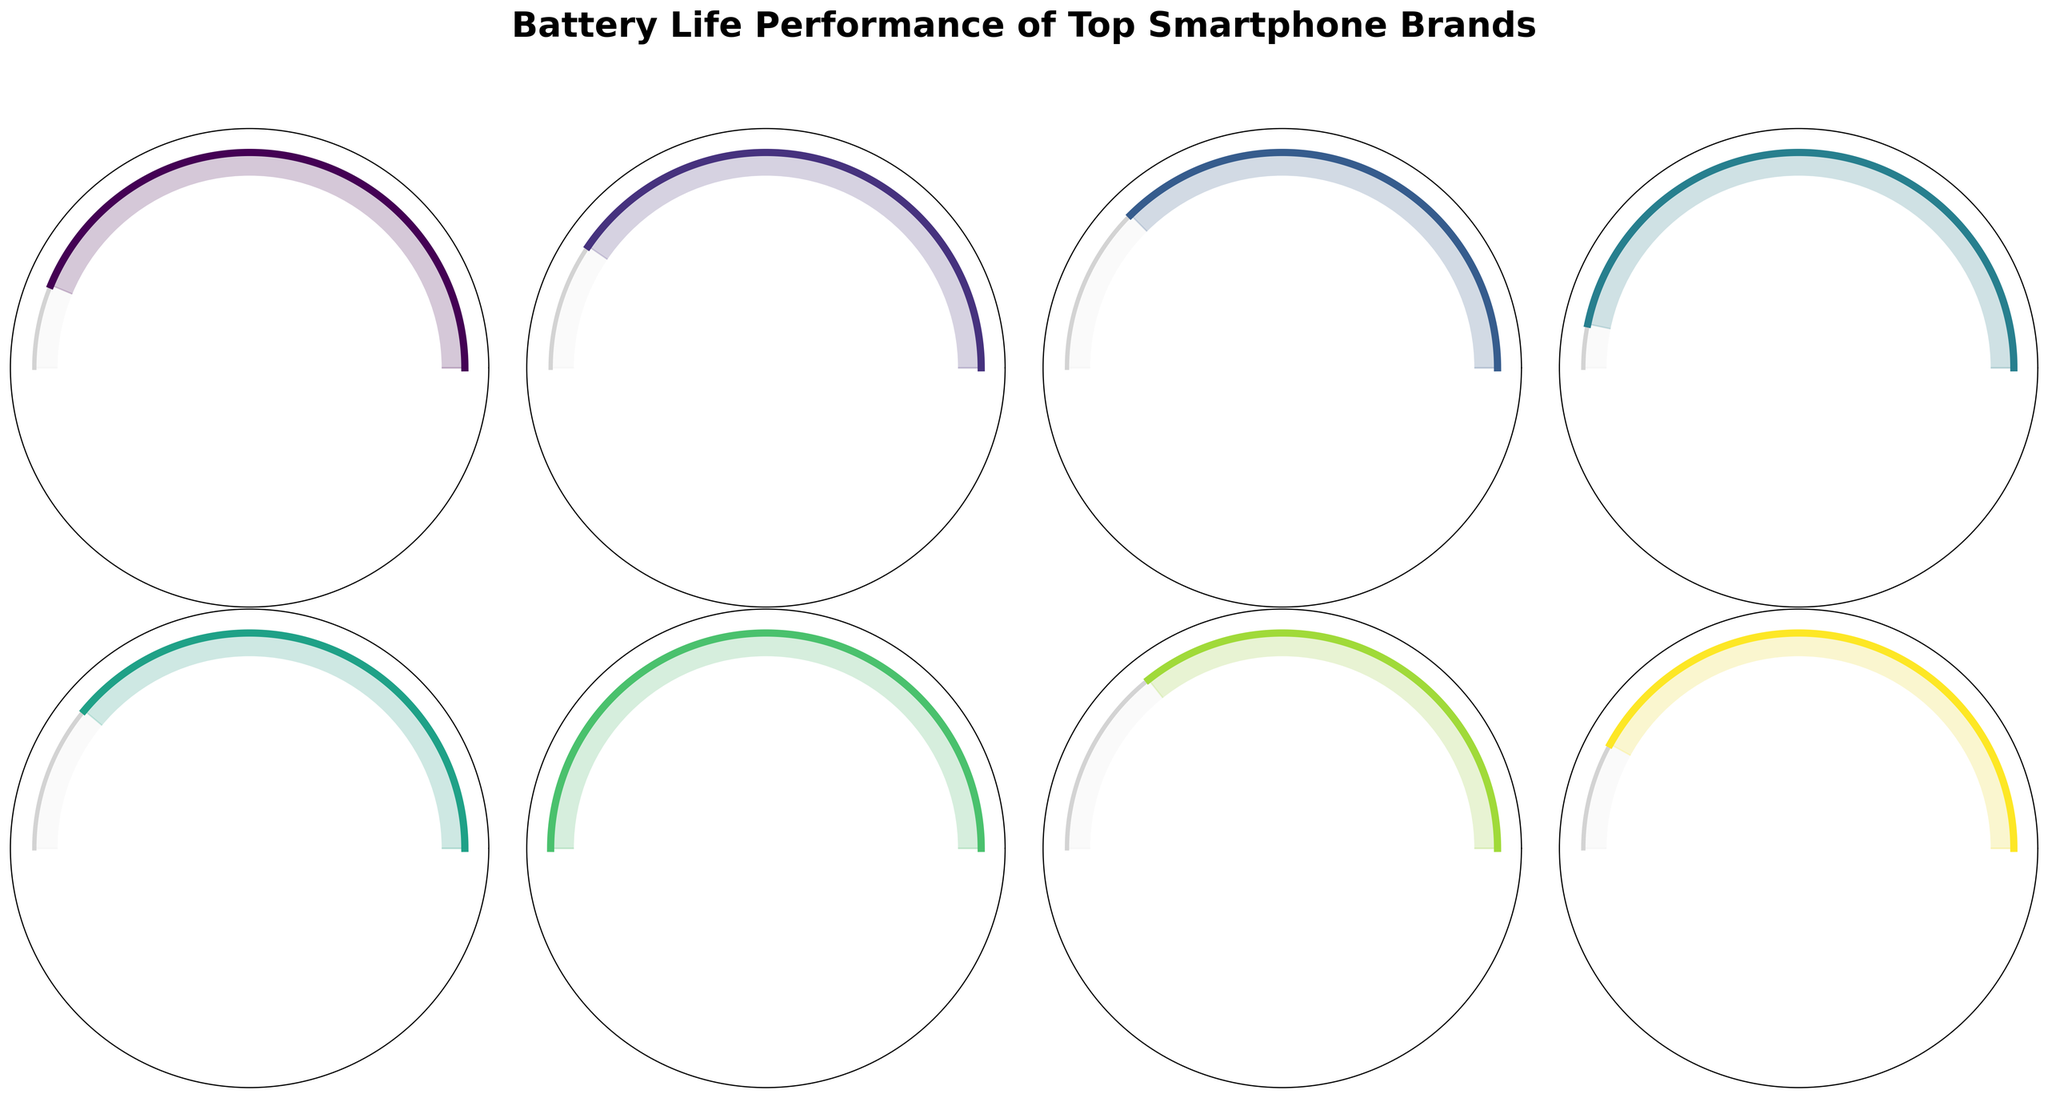What is the title of the figure? The title of the figure is displayed at the top of the plot in bold and large font size. It aligns with the central theme of the gauge charts.
Answer: Battery Life Performance of Top Smartphone Brands Which smartphone brand has the highest battery life performance? By examining each gauge chart, the ASUS ROG Phone 6 Pro shows the highest value at 32 hours.
Answer: ASUS ROG Phone 6 Pro What is the average battery life of all smartphone brands shown? Adding up the battery life of all brands (28 + 26 + 24 + 30 + 25 + 32 + 23 + 27) = 215. There are 8 brands, so the average is 215/8.
Answer: 26.875 hours Which smartphone brand has the least battery life performance? By analyzing the lowest values on each gauge chart, the Sony Xperia 1 V has the least value at 23 hours.
Answer: Sony Xperia 1 V How does the battery life of the iPhone 14 Pro Max compare to the Pixel 7 Pro? From the gauge charts, the iPhone 14 Pro Max has 28 hours and the Pixel 7 Pro has 24 hours. Comparing these values shows the iPhone has more battery life.
Answer: iPhone 14 Pro Max has 4 more hours What is the range of battery life performances across all brands? The range is the difference between the maximum and minimum values. The maximum is 32 hours (ASUS ROG Phone 6 Pro) and the minimum is 23 hours (Sony Xperia 1 V), so 32 - 23.
Answer: 9 hours Which two brands have the closest battery life performances? By comparing the differences between each pair of values, the Xiaomi 13 Pro (25 hours) and Google Pixel 7 Pro (24 hours) are closest, having a difference of 1 hour.
Answer: Xiaomi 13 Pro and Google Pixel 7 Pro What percentage of the max battery life does the Samsung Galaxy S23 Ultra have? The Samsung Galaxy S23 Ultra has a battery life of 26 hours. The maximum battery life among all brands is 32 hours (ASUS ROG Phone 6 Pro). The percentage is (26/32) * 100.
Answer: 81.25% Among the listed brands, how many have a battery life of 27 hours or more? From the gauge charts, five brands meet this criterion: Apple iPhone 14 Pro Max (28 hours), OnePlus 11 (30 hours), ASUS ROG Phone 6 Pro (32 hours), Motorola Edge 30 Ultra (27 hours), and Samsung Galaxy S23 Ultra (26 hours).
Answer: 5 brands 